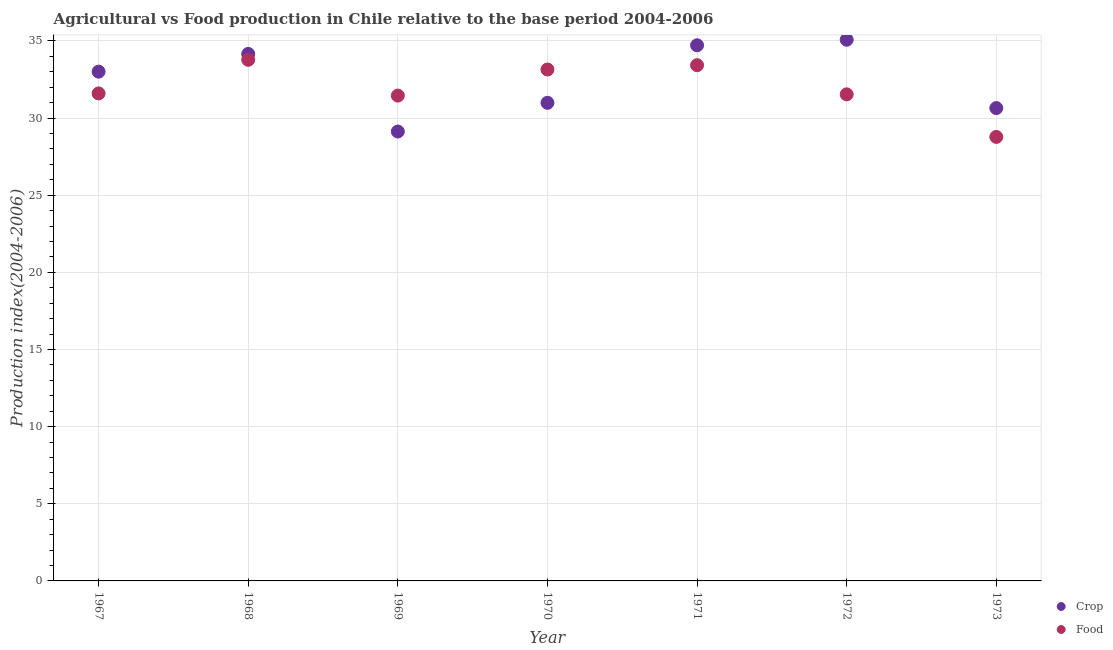How many different coloured dotlines are there?
Offer a terse response. 2. What is the food production index in 1970?
Offer a very short reply. 33.15. Across all years, what is the maximum food production index?
Your answer should be very brief. 33.78. Across all years, what is the minimum crop production index?
Your answer should be compact. 29.13. In which year was the food production index maximum?
Ensure brevity in your answer.  1968. In which year was the crop production index minimum?
Give a very brief answer. 1969. What is the total crop production index in the graph?
Provide a short and direct response. 227.74. What is the difference between the food production index in 1968 and that in 1972?
Your answer should be compact. 2.24. What is the difference between the crop production index in 1968 and the food production index in 1970?
Your answer should be compact. 1.01. What is the average crop production index per year?
Ensure brevity in your answer.  32.53. In the year 1973, what is the difference between the crop production index and food production index?
Ensure brevity in your answer.  1.87. What is the ratio of the food production index in 1967 to that in 1973?
Your response must be concise. 1.1. Is the difference between the food production index in 1967 and 1970 greater than the difference between the crop production index in 1967 and 1970?
Provide a short and direct response. No. What is the difference between the highest and the second highest food production index?
Your answer should be very brief. 0.35. Is the sum of the food production index in 1967 and 1968 greater than the maximum crop production index across all years?
Your response must be concise. Yes. Is the food production index strictly greater than the crop production index over the years?
Provide a succinct answer. No. Is the food production index strictly less than the crop production index over the years?
Provide a succinct answer. No. How many years are there in the graph?
Your answer should be compact. 7. Does the graph contain any zero values?
Offer a very short reply. No. Where does the legend appear in the graph?
Make the answer very short. Bottom right. How many legend labels are there?
Offer a terse response. 2. How are the legend labels stacked?
Make the answer very short. Vertical. What is the title of the graph?
Your response must be concise. Agricultural vs Food production in Chile relative to the base period 2004-2006. What is the label or title of the Y-axis?
Offer a very short reply. Production index(2004-2006). What is the Production index(2004-2006) of Crop in 1967?
Provide a succinct answer. 33.01. What is the Production index(2004-2006) of Food in 1967?
Keep it short and to the point. 31.6. What is the Production index(2004-2006) of Crop in 1968?
Provide a short and direct response. 34.16. What is the Production index(2004-2006) in Food in 1968?
Ensure brevity in your answer.  33.78. What is the Production index(2004-2006) in Crop in 1969?
Provide a short and direct response. 29.13. What is the Production index(2004-2006) in Food in 1969?
Provide a succinct answer. 31.46. What is the Production index(2004-2006) of Crop in 1970?
Provide a short and direct response. 30.99. What is the Production index(2004-2006) in Food in 1970?
Offer a terse response. 33.15. What is the Production index(2004-2006) of Crop in 1971?
Make the answer very short. 34.72. What is the Production index(2004-2006) of Food in 1971?
Ensure brevity in your answer.  33.43. What is the Production index(2004-2006) of Crop in 1972?
Give a very brief answer. 35.08. What is the Production index(2004-2006) in Food in 1972?
Offer a terse response. 31.54. What is the Production index(2004-2006) of Crop in 1973?
Give a very brief answer. 30.65. What is the Production index(2004-2006) in Food in 1973?
Provide a short and direct response. 28.78. Across all years, what is the maximum Production index(2004-2006) in Crop?
Your answer should be compact. 35.08. Across all years, what is the maximum Production index(2004-2006) of Food?
Keep it short and to the point. 33.78. Across all years, what is the minimum Production index(2004-2006) of Crop?
Keep it short and to the point. 29.13. Across all years, what is the minimum Production index(2004-2006) in Food?
Your answer should be very brief. 28.78. What is the total Production index(2004-2006) of Crop in the graph?
Your answer should be compact. 227.74. What is the total Production index(2004-2006) of Food in the graph?
Keep it short and to the point. 223.74. What is the difference between the Production index(2004-2006) in Crop in 1967 and that in 1968?
Your answer should be compact. -1.15. What is the difference between the Production index(2004-2006) of Food in 1967 and that in 1968?
Give a very brief answer. -2.18. What is the difference between the Production index(2004-2006) in Crop in 1967 and that in 1969?
Your answer should be compact. 3.88. What is the difference between the Production index(2004-2006) of Food in 1967 and that in 1969?
Your answer should be very brief. 0.14. What is the difference between the Production index(2004-2006) of Crop in 1967 and that in 1970?
Ensure brevity in your answer.  2.02. What is the difference between the Production index(2004-2006) of Food in 1967 and that in 1970?
Make the answer very short. -1.55. What is the difference between the Production index(2004-2006) of Crop in 1967 and that in 1971?
Ensure brevity in your answer.  -1.71. What is the difference between the Production index(2004-2006) in Food in 1967 and that in 1971?
Your answer should be very brief. -1.83. What is the difference between the Production index(2004-2006) in Crop in 1967 and that in 1972?
Offer a terse response. -2.07. What is the difference between the Production index(2004-2006) in Food in 1967 and that in 1972?
Ensure brevity in your answer.  0.06. What is the difference between the Production index(2004-2006) of Crop in 1967 and that in 1973?
Make the answer very short. 2.36. What is the difference between the Production index(2004-2006) in Food in 1967 and that in 1973?
Keep it short and to the point. 2.82. What is the difference between the Production index(2004-2006) of Crop in 1968 and that in 1969?
Ensure brevity in your answer.  5.03. What is the difference between the Production index(2004-2006) in Food in 1968 and that in 1969?
Provide a short and direct response. 2.32. What is the difference between the Production index(2004-2006) in Crop in 1968 and that in 1970?
Make the answer very short. 3.17. What is the difference between the Production index(2004-2006) of Food in 1968 and that in 1970?
Your answer should be very brief. 0.63. What is the difference between the Production index(2004-2006) in Crop in 1968 and that in 1971?
Provide a succinct answer. -0.56. What is the difference between the Production index(2004-2006) in Crop in 1968 and that in 1972?
Keep it short and to the point. -0.92. What is the difference between the Production index(2004-2006) of Food in 1968 and that in 1972?
Your response must be concise. 2.24. What is the difference between the Production index(2004-2006) in Crop in 1968 and that in 1973?
Give a very brief answer. 3.51. What is the difference between the Production index(2004-2006) in Crop in 1969 and that in 1970?
Make the answer very short. -1.86. What is the difference between the Production index(2004-2006) of Food in 1969 and that in 1970?
Provide a succinct answer. -1.69. What is the difference between the Production index(2004-2006) in Crop in 1969 and that in 1971?
Offer a very short reply. -5.59. What is the difference between the Production index(2004-2006) in Food in 1969 and that in 1971?
Ensure brevity in your answer.  -1.97. What is the difference between the Production index(2004-2006) in Crop in 1969 and that in 1972?
Your answer should be compact. -5.95. What is the difference between the Production index(2004-2006) of Food in 1969 and that in 1972?
Your response must be concise. -0.08. What is the difference between the Production index(2004-2006) in Crop in 1969 and that in 1973?
Make the answer very short. -1.52. What is the difference between the Production index(2004-2006) of Food in 1969 and that in 1973?
Your response must be concise. 2.68. What is the difference between the Production index(2004-2006) in Crop in 1970 and that in 1971?
Give a very brief answer. -3.73. What is the difference between the Production index(2004-2006) of Food in 1970 and that in 1971?
Offer a very short reply. -0.28. What is the difference between the Production index(2004-2006) in Crop in 1970 and that in 1972?
Your response must be concise. -4.09. What is the difference between the Production index(2004-2006) in Food in 1970 and that in 1972?
Make the answer very short. 1.61. What is the difference between the Production index(2004-2006) of Crop in 1970 and that in 1973?
Your answer should be compact. 0.34. What is the difference between the Production index(2004-2006) in Food in 1970 and that in 1973?
Provide a succinct answer. 4.37. What is the difference between the Production index(2004-2006) of Crop in 1971 and that in 1972?
Make the answer very short. -0.36. What is the difference between the Production index(2004-2006) in Food in 1971 and that in 1972?
Provide a succinct answer. 1.89. What is the difference between the Production index(2004-2006) in Crop in 1971 and that in 1973?
Your answer should be very brief. 4.07. What is the difference between the Production index(2004-2006) in Food in 1971 and that in 1973?
Offer a very short reply. 4.65. What is the difference between the Production index(2004-2006) of Crop in 1972 and that in 1973?
Make the answer very short. 4.43. What is the difference between the Production index(2004-2006) in Food in 1972 and that in 1973?
Provide a succinct answer. 2.76. What is the difference between the Production index(2004-2006) in Crop in 1967 and the Production index(2004-2006) in Food in 1968?
Your answer should be compact. -0.77. What is the difference between the Production index(2004-2006) of Crop in 1967 and the Production index(2004-2006) of Food in 1969?
Your answer should be very brief. 1.55. What is the difference between the Production index(2004-2006) of Crop in 1967 and the Production index(2004-2006) of Food in 1970?
Ensure brevity in your answer.  -0.14. What is the difference between the Production index(2004-2006) in Crop in 1967 and the Production index(2004-2006) in Food in 1971?
Your answer should be compact. -0.42. What is the difference between the Production index(2004-2006) in Crop in 1967 and the Production index(2004-2006) in Food in 1972?
Ensure brevity in your answer.  1.47. What is the difference between the Production index(2004-2006) of Crop in 1967 and the Production index(2004-2006) of Food in 1973?
Give a very brief answer. 4.23. What is the difference between the Production index(2004-2006) of Crop in 1968 and the Production index(2004-2006) of Food in 1970?
Your answer should be very brief. 1.01. What is the difference between the Production index(2004-2006) in Crop in 1968 and the Production index(2004-2006) in Food in 1971?
Provide a succinct answer. 0.73. What is the difference between the Production index(2004-2006) in Crop in 1968 and the Production index(2004-2006) in Food in 1972?
Your answer should be very brief. 2.62. What is the difference between the Production index(2004-2006) of Crop in 1968 and the Production index(2004-2006) of Food in 1973?
Provide a short and direct response. 5.38. What is the difference between the Production index(2004-2006) of Crop in 1969 and the Production index(2004-2006) of Food in 1970?
Your response must be concise. -4.02. What is the difference between the Production index(2004-2006) of Crop in 1969 and the Production index(2004-2006) of Food in 1972?
Provide a succinct answer. -2.41. What is the difference between the Production index(2004-2006) in Crop in 1969 and the Production index(2004-2006) in Food in 1973?
Provide a succinct answer. 0.35. What is the difference between the Production index(2004-2006) of Crop in 1970 and the Production index(2004-2006) of Food in 1971?
Provide a succinct answer. -2.44. What is the difference between the Production index(2004-2006) of Crop in 1970 and the Production index(2004-2006) of Food in 1972?
Your response must be concise. -0.55. What is the difference between the Production index(2004-2006) of Crop in 1970 and the Production index(2004-2006) of Food in 1973?
Offer a terse response. 2.21. What is the difference between the Production index(2004-2006) in Crop in 1971 and the Production index(2004-2006) in Food in 1972?
Your answer should be compact. 3.18. What is the difference between the Production index(2004-2006) of Crop in 1971 and the Production index(2004-2006) of Food in 1973?
Keep it short and to the point. 5.94. What is the difference between the Production index(2004-2006) of Crop in 1972 and the Production index(2004-2006) of Food in 1973?
Provide a succinct answer. 6.3. What is the average Production index(2004-2006) in Crop per year?
Ensure brevity in your answer.  32.53. What is the average Production index(2004-2006) of Food per year?
Make the answer very short. 31.96. In the year 1967, what is the difference between the Production index(2004-2006) in Crop and Production index(2004-2006) in Food?
Offer a very short reply. 1.41. In the year 1968, what is the difference between the Production index(2004-2006) in Crop and Production index(2004-2006) in Food?
Provide a succinct answer. 0.38. In the year 1969, what is the difference between the Production index(2004-2006) of Crop and Production index(2004-2006) of Food?
Ensure brevity in your answer.  -2.33. In the year 1970, what is the difference between the Production index(2004-2006) in Crop and Production index(2004-2006) in Food?
Your response must be concise. -2.16. In the year 1971, what is the difference between the Production index(2004-2006) in Crop and Production index(2004-2006) in Food?
Make the answer very short. 1.29. In the year 1972, what is the difference between the Production index(2004-2006) of Crop and Production index(2004-2006) of Food?
Keep it short and to the point. 3.54. In the year 1973, what is the difference between the Production index(2004-2006) of Crop and Production index(2004-2006) of Food?
Keep it short and to the point. 1.87. What is the ratio of the Production index(2004-2006) of Crop in 1967 to that in 1968?
Offer a terse response. 0.97. What is the ratio of the Production index(2004-2006) in Food in 1967 to that in 1968?
Make the answer very short. 0.94. What is the ratio of the Production index(2004-2006) in Crop in 1967 to that in 1969?
Make the answer very short. 1.13. What is the ratio of the Production index(2004-2006) in Crop in 1967 to that in 1970?
Ensure brevity in your answer.  1.07. What is the ratio of the Production index(2004-2006) of Food in 1967 to that in 1970?
Keep it short and to the point. 0.95. What is the ratio of the Production index(2004-2006) in Crop in 1967 to that in 1971?
Provide a short and direct response. 0.95. What is the ratio of the Production index(2004-2006) in Food in 1967 to that in 1971?
Keep it short and to the point. 0.95. What is the ratio of the Production index(2004-2006) of Crop in 1967 to that in 1972?
Your answer should be very brief. 0.94. What is the ratio of the Production index(2004-2006) of Crop in 1967 to that in 1973?
Give a very brief answer. 1.08. What is the ratio of the Production index(2004-2006) of Food in 1967 to that in 1973?
Provide a short and direct response. 1.1. What is the ratio of the Production index(2004-2006) of Crop in 1968 to that in 1969?
Offer a very short reply. 1.17. What is the ratio of the Production index(2004-2006) in Food in 1968 to that in 1969?
Offer a terse response. 1.07. What is the ratio of the Production index(2004-2006) of Crop in 1968 to that in 1970?
Keep it short and to the point. 1.1. What is the ratio of the Production index(2004-2006) of Food in 1968 to that in 1970?
Offer a very short reply. 1.02. What is the ratio of the Production index(2004-2006) of Crop in 1968 to that in 1971?
Your response must be concise. 0.98. What is the ratio of the Production index(2004-2006) of Food in 1968 to that in 1971?
Ensure brevity in your answer.  1.01. What is the ratio of the Production index(2004-2006) in Crop in 1968 to that in 1972?
Your response must be concise. 0.97. What is the ratio of the Production index(2004-2006) of Food in 1968 to that in 1972?
Make the answer very short. 1.07. What is the ratio of the Production index(2004-2006) of Crop in 1968 to that in 1973?
Provide a short and direct response. 1.11. What is the ratio of the Production index(2004-2006) in Food in 1968 to that in 1973?
Make the answer very short. 1.17. What is the ratio of the Production index(2004-2006) in Food in 1969 to that in 1970?
Ensure brevity in your answer.  0.95. What is the ratio of the Production index(2004-2006) in Crop in 1969 to that in 1971?
Give a very brief answer. 0.84. What is the ratio of the Production index(2004-2006) in Food in 1969 to that in 1971?
Offer a terse response. 0.94. What is the ratio of the Production index(2004-2006) in Crop in 1969 to that in 1972?
Ensure brevity in your answer.  0.83. What is the ratio of the Production index(2004-2006) in Crop in 1969 to that in 1973?
Provide a short and direct response. 0.95. What is the ratio of the Production index(2004-2006) of Food in 1969 to that in 1973?
Offer a very short reply. 1.09. What is the ratio of the Production index(2004-2006) of Crop in 1970 to that in 1971?
Offer a very short reply. 0.89. What is the ratio of the Production index(2004-2006) in Food in 1970 to that in 1971?
Make the answer very short. 0.99. What is the ratio of the Production index(2004-2006) of Crop in 1970 to that in 1972?
Provide a short and direct response. 0.88. What is the ratio of the Production index(2004-2006) of Food in 1970 to that in 1972?
Your answer should be very brief. 1.05. What is the ratio of the Production index(2004-2006) of Crop in 1970 to that in 1973?
Your response must be concise. 1.01. What is the ratio of the Production index(2004-2006) of Food in 1970 to that in 1973?
Your answer should be compact. 1.15. What is the ratio of the Production index(2004-2006) in Crop in 1971 to that in 1972?
Your answer should be compact. 0.99. What is the ratio of the Production index(2004-2006) of Food in 1971 to that in 1972?
Keep it short and to the point. 1.06. What is the ratio of the Production index(2004-2006) in Crop in 1971 to that in 1973?
Offer a very short reply. 1.13. What is the ratio of the Production index(2004-2006) in Food in 1971 to that in 1973?
Ensure brevity in your answer.  1.16. What is the ratio of the Production index(2004-2006) of Crop in 1972 to that in 1973?
Offer a terse response. 1.14. What is the ratio of the Production index(2004-2006) of Food in 1972 to that in 1973?
Ensure brevity in your answer.  1.1. What is the difference between the highest and the second highest Production index(2004-2006) of Crop?
Ensure brevity in your answer.  0.36. What is the difference between the highest and the lowest Production index(2004-2006) of Crop?
Make the answer very short. 5.95. What is the difference between the highest and the lowest Production index(2004-2006) of Food?
Your response must be concise. 5. 